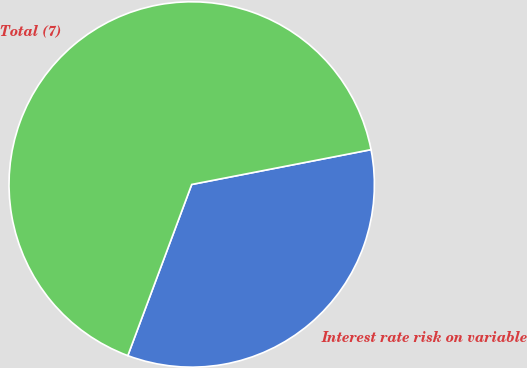<chart> <loc_0><loc_0><loc_500><loc_500><pie_chart><fcel>Interest rate risk on variable<fcel>Total (7)<nl><fcel>33.74%<fcel>66.26%<nl></chart> 